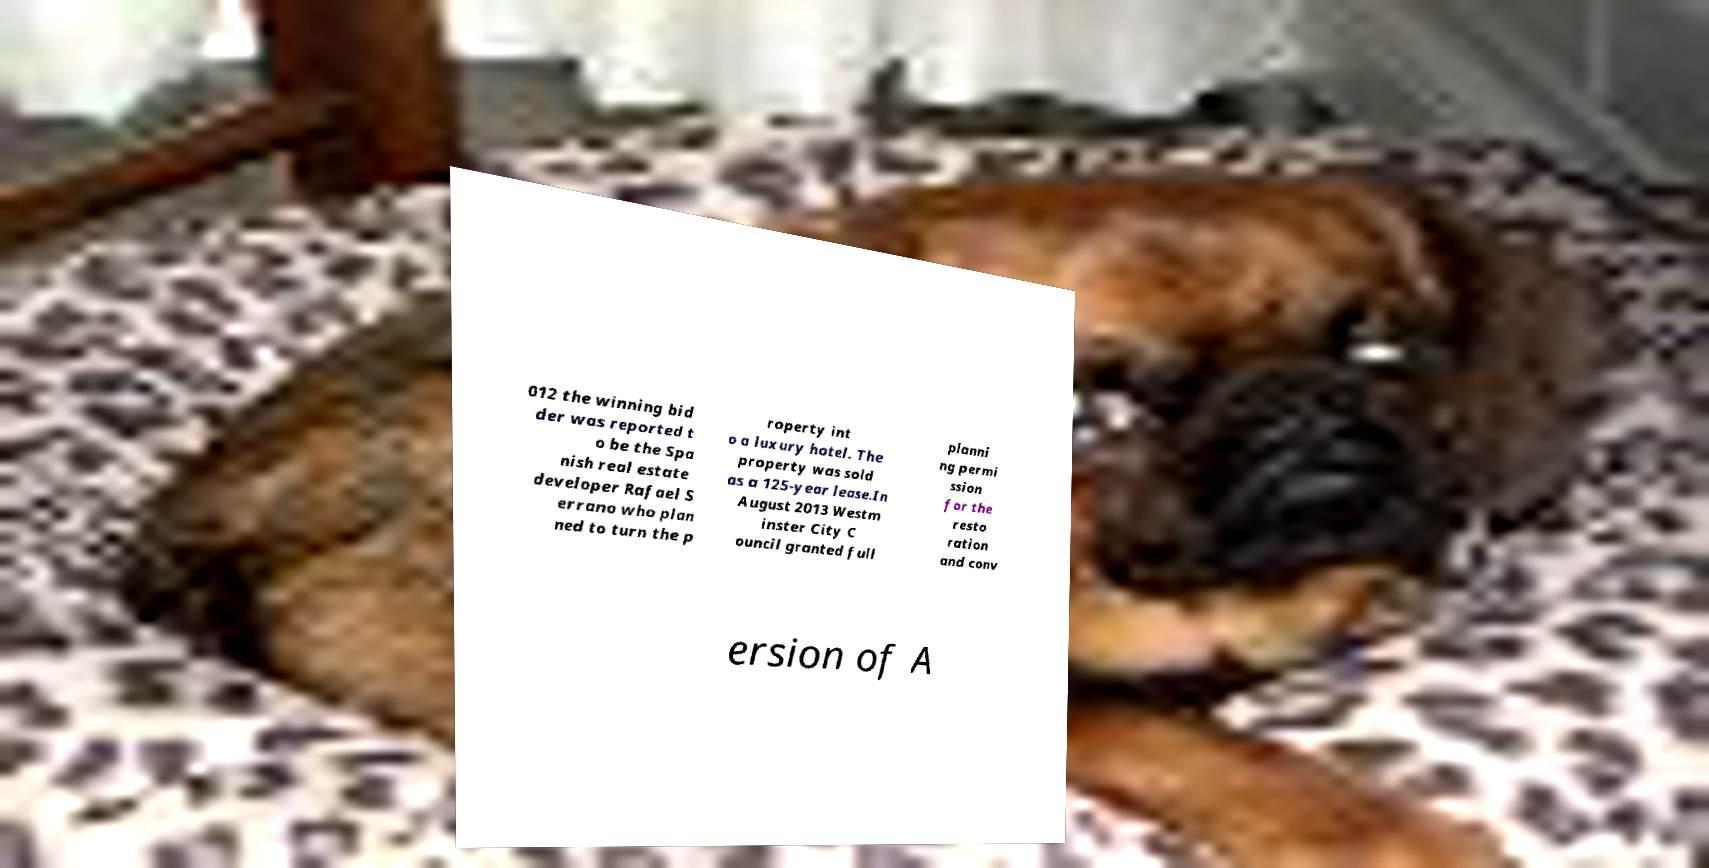Please identify and transcribe the text found in this image. 012 the winning bid der was reported t o be the Spa nish real estate developer Rafael S errano who plan ned to turn the p roperty int o a luxury hotel. The property was sold as a 125-year lease.In August 2013 Westm inster City C ouncil granted full planni ng permi ssion for the resto ration and conv ersion of A 